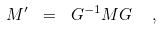Convert formula to latex. <formula><loc_0><loc_0><loc_500><loc_500>M ^ { \prime } \ = \ G ^ { - 1 } M G \ \ ,</formula> 